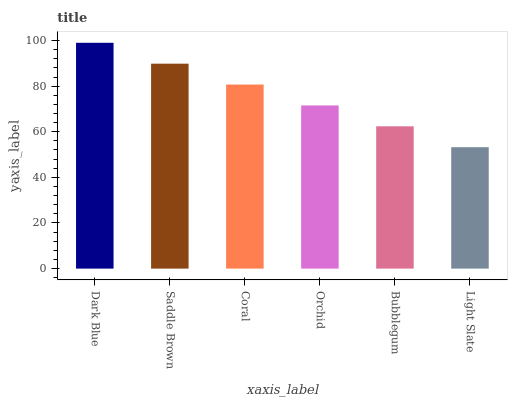Is Light Slate the minimum?
Answer yes or no. Yes. Is Dark Blue the maximum?
Answer yes or no. Yes. Is Saddle Brown the minimum?
Answer yes or no. No. Is Saddle Brown the maximum?
Answer yes or no. No. Is Dark Blue greater than Saddle Brown?
Answer yes or no. Yes. Is Saddle Brown less than Dark Blue?
Answer yes or no. Yes. Is Saddle Brown greater than Dark Blue?
Answer yes or no. No. Is Dark Blue less than Saddle Brown?
Answer yes or no. No. Is Coral the high median?
Answer yes or no. Yes. Is Orchid the low median?
Answer yes or no. Yes. Is Bubblegum the high median?
Answer yes or no. No. Is Light Slate the low median?
Answer yes or no. No. 